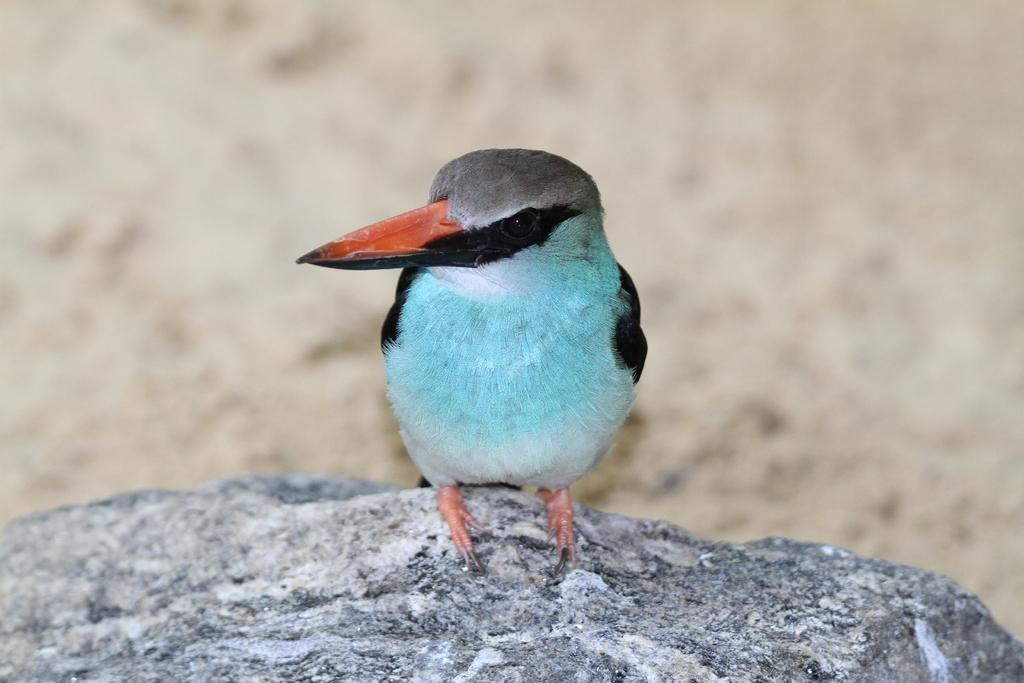What type of animal is in the image? There is a bird in the image. Where is the bird located? The bird is on a rock. What can be seen in the center of the image? The bird and rock are in the center of the image. What letter does the bird spell out with its wings in the image? There is no indication in the image that the bird is spelling out a letter with its wings. 